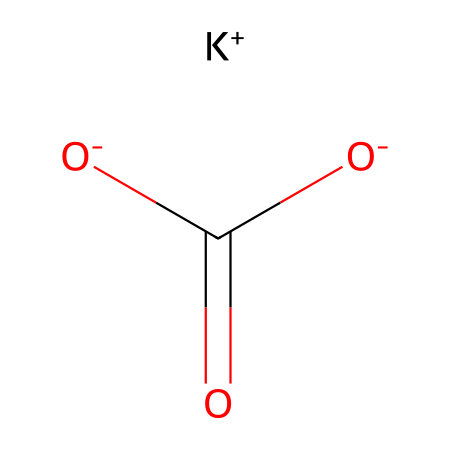What is the molecular formula of potassium bicarbonate? The chemical composition can be derived from the SMILES representation. It includes one potassium atom (K), three oxygen atoms (O), one carbon atom (C), and one hydrogen atom (H) from the bicarbonate portion (HCO₃). Hence, the molecular formula is KHCO₃.
Answer: KHCO₃ How many distinct elements are present in potassium bicarbonate? Analyzing the SMILES representation, we can identify potassium (K), hydrogen (H), carbon (C), and oxygen (O) as the elements, totaling four distinct elements.
Answer: 4 What type of ion is represented by the K+ in this structure? The K+ represents a cation, which is a positively charged ion. Potassium typically loses one electron to form this cation.
Answer: cation What kind of bond is present between carbon and oxygen in the bicarbonate? The SMILES indicates a double bond between the carbon atom and one of the oxygen atoms, denoting a carbonyl functional group within the bicarbonate ion.
Answer: double bond What role does potassium bicarbonate play in antacid tablets? The bicarbonate ion reacts with stomach acid (HCl) to neutralize excess acidity, thus functioning as an antacid.
Answer: neutralizing agent What is the total number of hydrogen atoms in the potassium bicarbonate structure? By examining the chemical structure, there is one hydrogen from the bicarbonate group, which indicates a total of one hydrogen atom.
Answer: 1 